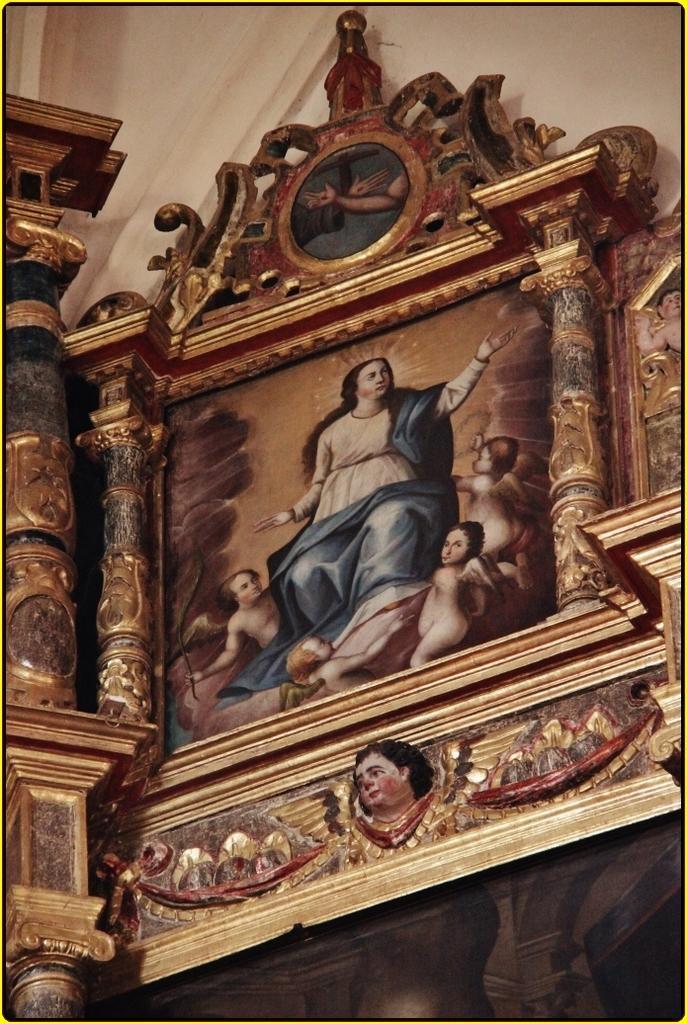How would you summarize this image in a sentence or two? In this picture we can see the wall, frame. We can see the depictions of the people. 